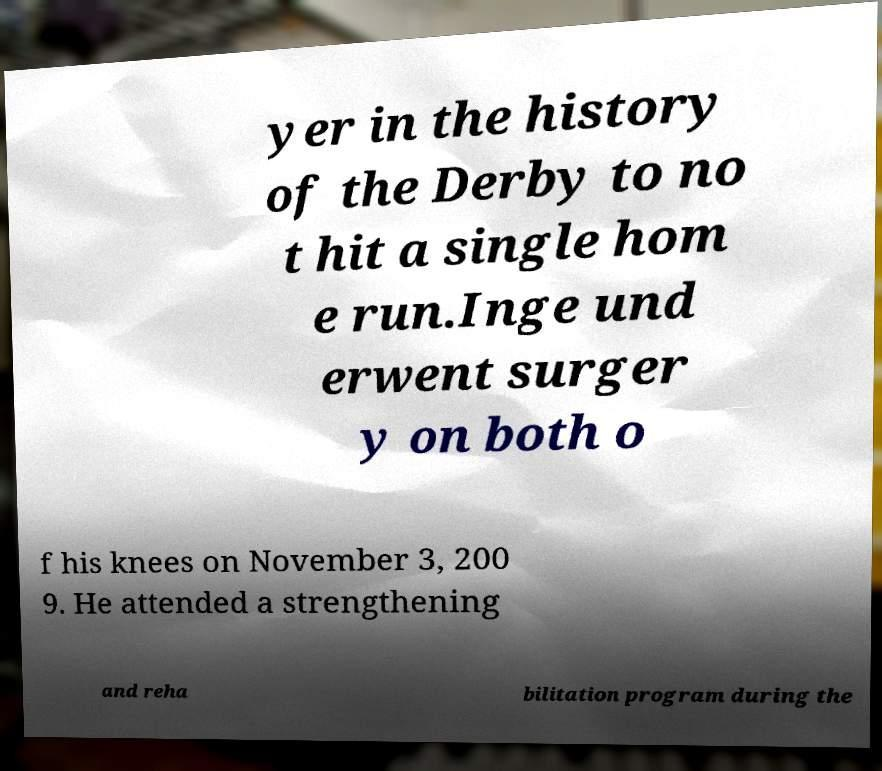Could you assist in decoding the text presented in this image and type it out clearly? yer in the history of the Derby to no t hit a single hom e run.Inge und erwent surger y on both o f his knees on November 3, 200 9. He attended a strengthening and reha bilitation program during the 